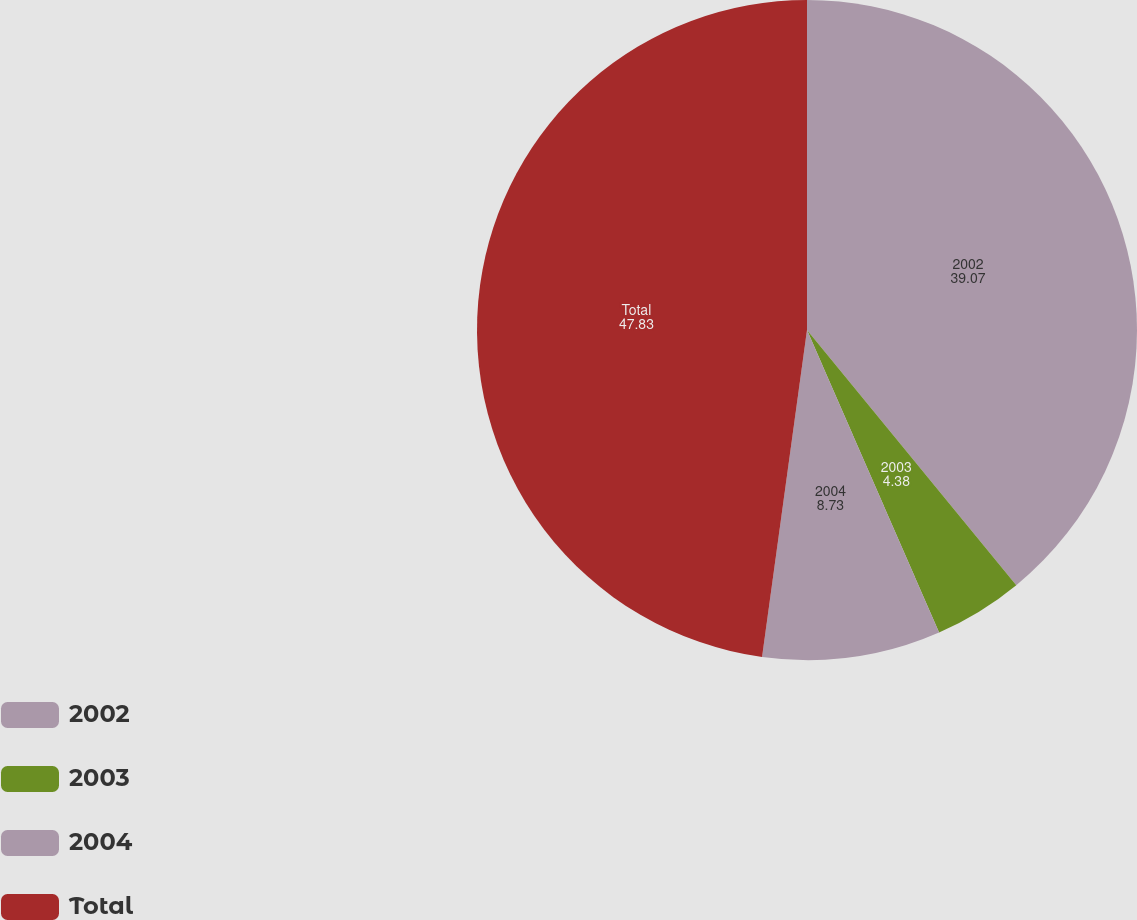<chart> <loc_0><loc_0><loc_500><loc_500><pie_chart><fcel>2002<fcel>2003<fcel>2004<fcel>Total<nl><fcel>39.07%<fcel>4.38%<fcel>8.73%<fcel>47.83%<nl></chart> 